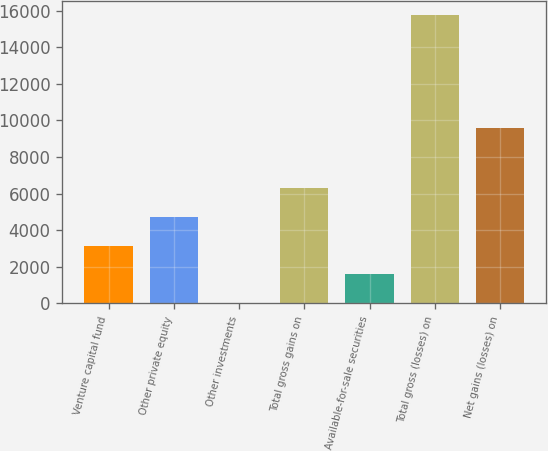Convert chart. <chart><loc_0><loc_0><loc_500><loc_500><bar_chart><fcel>Venture capital fund<fcel>Other private equity<fcel>Other investments<fcel>Total gross gains on<fcel>Available-for-sale securities<fcel>Total gross (losses) on<fcel>Net gains (losses) on<nl><fcel>3161.2<fcel>4735.8<fcel>12<fcel>6310.4<fcel>1586.6<fcel>15758<fcel>9614<nl></chart> 